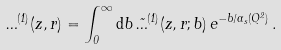<formula> <loc_0><loc_0><loc_500><loc_500>\Phi ^ { ( 1 ) } ( z , r ) = \int _ { 0 } ^ { \infty } { \mathrm d } b \, \tilde { \Phi } ^ { ( 1 ) } ( z , r ; b ) \, e ^ { - b / \alpha _ { s } ( Q ^ { 2 } ) } \, .</formula> 